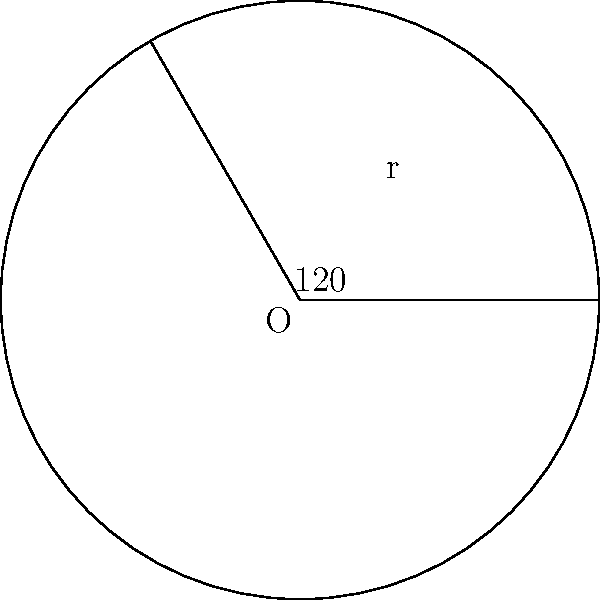As a fitness trainer, you're designing a healthier pizza with a circular shape. If the pizza has a radius of 10 inches and you want to cut a slice with a central angle of 120°, what is the area of this slice in square inches? Round your answer to two decimal places. To find the area of a circular sector (pizza slice), we can follow these steps:

1) The formula for the area of a circular sector is:

   $$A = \frac{\theta}{360°} \pi r^2$$

   Where $\theta$ is the central angle in degrees, and $r$ is the radius.

2) We're given:
   $\theta = 120°$
   $r = 10$ inches

3) Let's substitute these values into our formula:

   $$A = \frac{120°}{360°} \pi (10\text{ in})^2$$

4) Simplify:
   $$A = \frac{1}{3} \pi (100\text{ in}^2)$$

5) Calculate:
   $$A = \frac{1}{3} \times 3.14159 \times 100\text{ in}^2$$
   $$A \approx 104.72\text{ in}^2$$

6) Rounding to two decimal places:
   $$A \approx 104.72\text{ in}^2$$

This area represents the size of the pizza slice, which can be useful for portion control in creating healthier pizza options.
Answer: 104.72 in² 